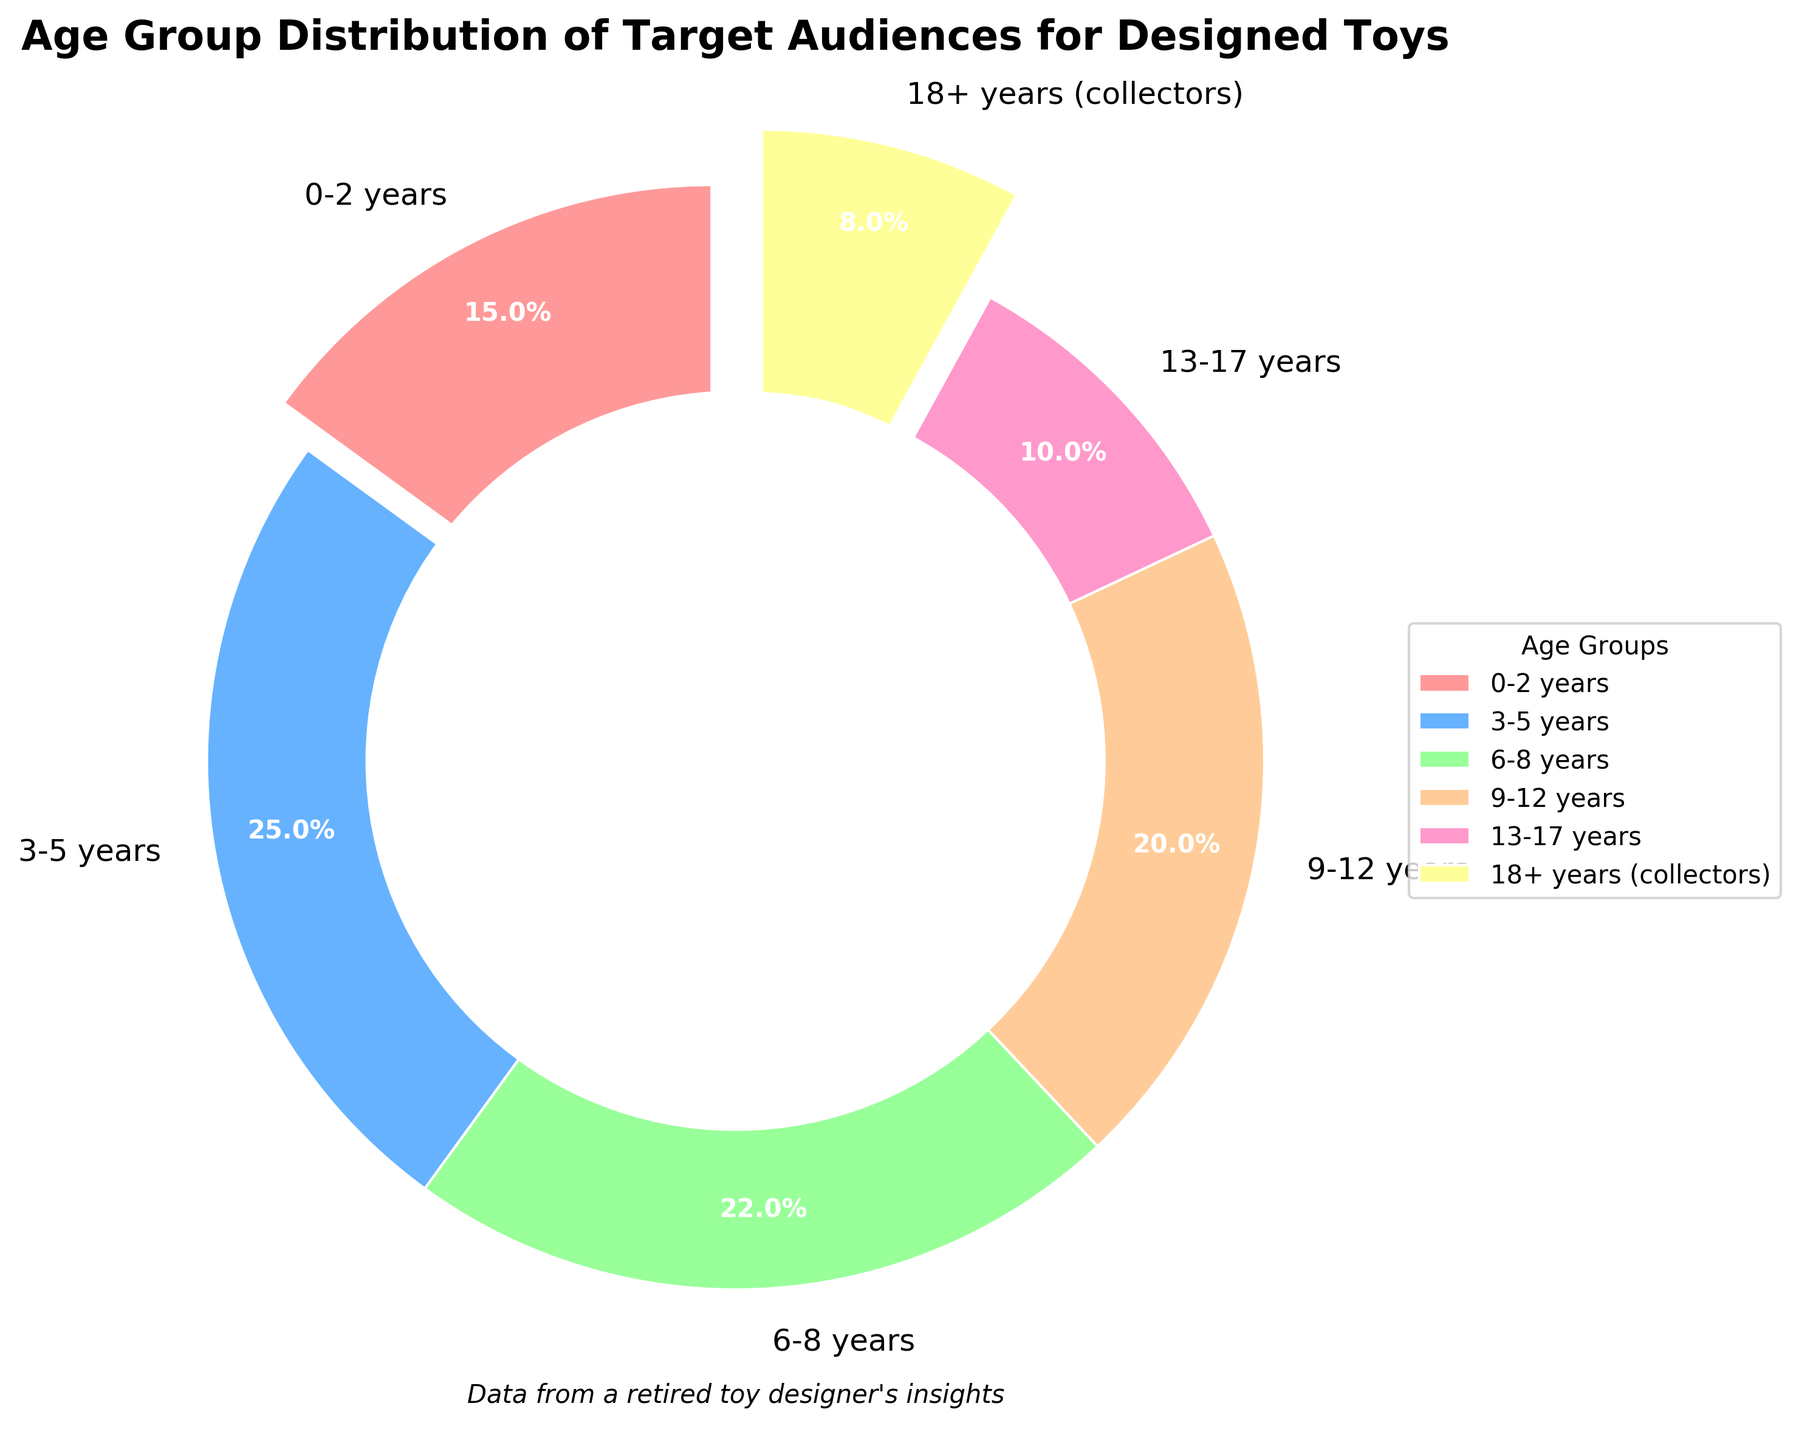Which age group has the highest percentage? The age group with the highest percentage can be identified by looking for the largest slice in the pie chart. The "3-5 years" group has the largest slice.
Answer: 3-5 years Which age group has the lowest percentage? The age group with the lowest percentage can be identified by looking for the smallest slice in the pie chart. The "18+ years (collectors)" group has the smallest slice.
Answer: 18+ years (collectors) What is the total percentage of the target audience that is under 6 years old (0-5 years)? Add the percentages of the age groups "0-2 years" and "3-5 years": 15% + 25% = 40%.
Answer: 40% How does the percentage of the "6-8 years" group compare to the "9-12 years" group? Compare the percentages of the two age groups: "6-8 years" is 22% and "9-12 years" is 20%. "6-8 years" has a higher percentage.
Answer: 6-8 years > 9-12 years What is the difference in percentage between the "3-5 years" group and the "13-17 years" group? Subtract the percentage of the "13-17 years" group from the "3-5 years" group: 25% - 10% = 15%.
Answer: 15% What is the total percentage of the target audience aged 13 years and older? Add the percentages of the "13-17 years" and "18+ years (collectors)" groups: 10% + 8% = 18%.
Answer: 18% Which age group is represented by the red slice in the pie chart? The color red corresponds to the first slice "0-2 years" in the given color scheme of the pie chart.
Answer: 0-2 years Which two age groups have percentages that are closest to each other? Compare all age group percentages to find the smallest difference. The "6-8 years" group (22%) and "9-12 years" group (20%) have the closest percentages with a difference of 2%.
Answer: 6-8 years and 9-12 years What percentage of the target audience is between 6 and 12 years old (inclusive)? Add the percentages of the "6-8 years" and "9-12 years" groups: 22% + 20% = 42%.
Answer: 42% 